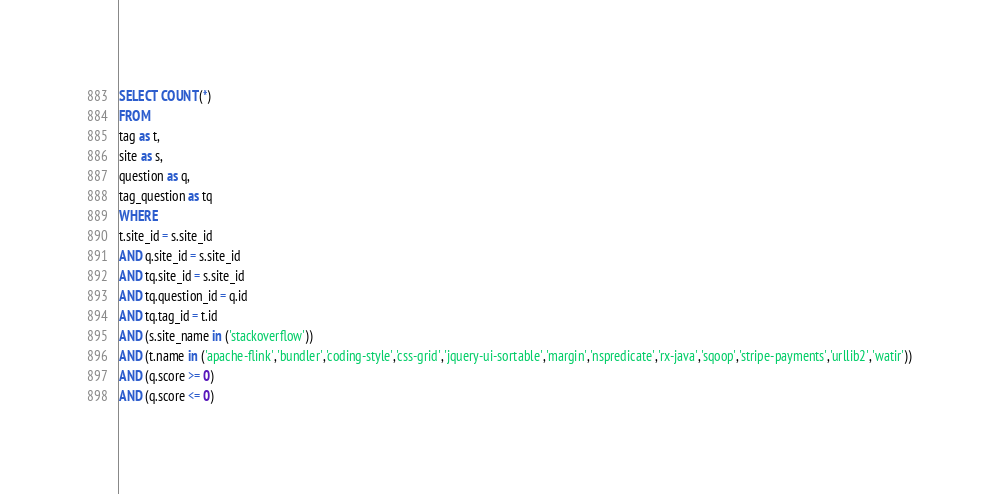Convert code to text. <code><loc_0><loc_0><loc_500><loc_500><_SQL_>SELECT COUNT(*)
FROM
tag as t,
site as s,
question as q,
tag_question as tq
WHERE
t.site_id = s.site_id
AND q.site_id = s.site_id
AND tq.site_id = s.site_id
AND tq.question_id = q.id
AND tq.tag_id = t.id
AND (s.site_name in ('stackoverflow'))
AND (t.name in ('apache-flink','bundler','coding-style','css-grid','jquery-ui-sortable','margin','nspredicate','rx-java','sqoop','stripe-payments','urllib2','watir'))
AND (q.score >= 0)
AND (q.score <= 0)
</code> 